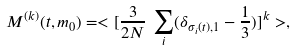Convert formula to latex. <formula><loc_0><loc_0><loc_500><loc_500>M ^ { ( k ) } ( t , m _ { 0 } ) = < [ \frac { 3 } { 2 N } \, \sum _ { i } ( \delta _ { \sigma _ { i } ( t ) , 1 } - \frac { 1 } { 3 } ) ] ^ { k } > ,</formula> 